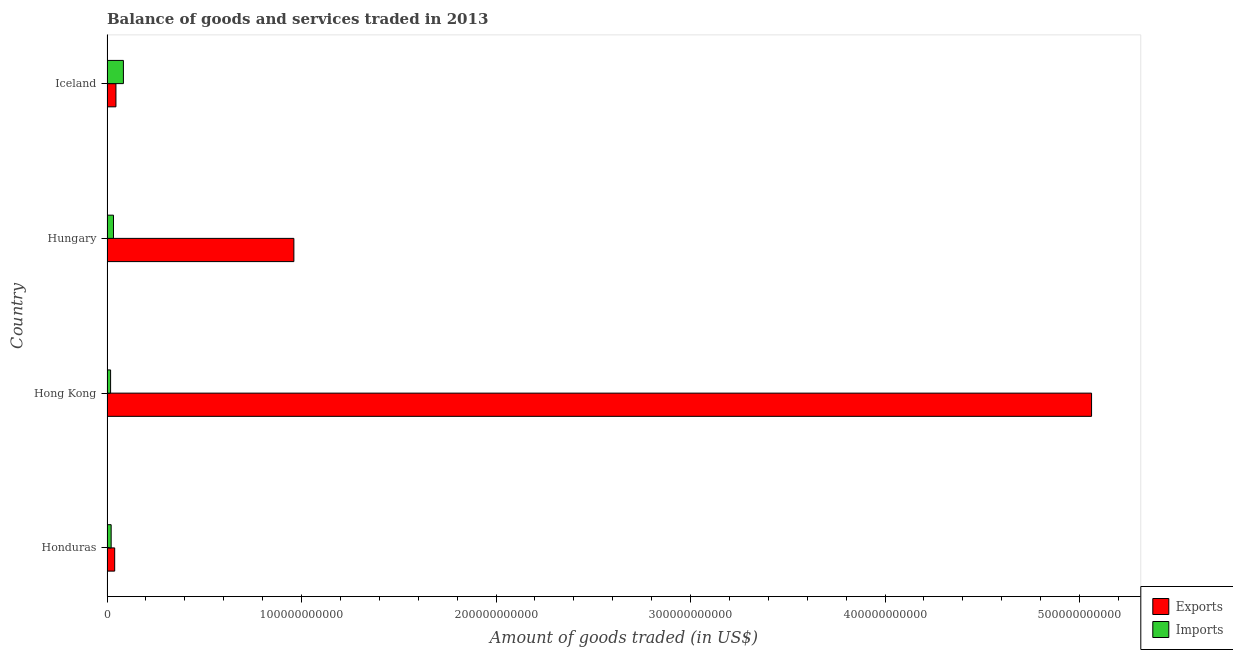How many different coloured bars are there?
Your answer should be very brief. 2. How many groups of bars are there?
Your answer should be compact. 4. Are the number of bars on each tick of the Y-axis equal?
Your answer should be very brief. Yes. How many bars are there on the 1st tick from the top?
Ensure brevity in your answer.  2. What is the label of the 1st group of bars from the top?
Give a very brief answer. Iceland. In how many cases, is the number of bars for a given country not equal to the number of legend labels?
Ensure brevity in your answer.  0. What is the amount of goods imported in Iceland?
Your answer should be compact. 8.43e+09. Across all countries, what is the maximum amount of goods imported?
Keep it short and to the point. 8.43e+09. Across all countries, what is the minimum amount of goods imported?
Your response must be concise. 1.85e+09. In which country was the amount of goods exported maximum?
Give a very brief answer. Hong Kong. In which country was the amount of goods exported minimum?
Give a very brief answer. Honduras. What is the total amount of goods imported in the graph?
Keep it short and to the point. 1.57e+1. What is the difference between the amount of goods imported in Honduras and that in Hong Kong?
Ensure brevity in your answer.  2.89e+08. What is the difference between the amount of goods imported in Hungary and the amount of goods exported in Honduras?
Provide a succinct answer. -6.21e+08. What is the average amount of goods imported per country?
Ensure brevity in your answer.  3.94e+09. What is the difference between the amount of goods exported and amount of goods imported in Hong Kong?
Your answer should be compact. 5.04e+11. In how many countries, is the amount of goods exported greater than 400000000000 US$?
Provide a short and direct response. 1. What is the ratio of the amount of goods imported in Hong Kong to that in Hungary?
Offer a terse response. 0.56. Is the amount of goods exported in Honduras less than that in Hong Kong?
Offer a terse response. Yes. What is the difference between the highest and the second highest amount of goods exported?
Provide a short and direct response. 4.10e+11. What is the difference between the highest and the lowest amount of goods imported?
Ensure brevity in your answer.  6.58e+09. In how many countries, is the amount of goods imported greater than the average amount of goods imported taken over all countries?
Keep it short and to the point. 1. Is the sum of the amount of goods imported in Hong Kong and Hungary greater than the maximum amount of goods exported across all countries?
Your answer should be compact. No. What does the 2nd bar from the top in Hong Kong represents?
Offer a terse response. Exports. What does the 1st bar from the bottom in Hungary represents?
Keep it short and to the point. Exports. How many bars are there?
Provide a succinct answer. 8. Are all the bars in the graph horizontal?
Make the answer very short. Yes. How many countries are there in the graph?
Provide a short and direct response. 4. What is the difference between two consecutive major ticks on the X-axis?
Offer a very short reply. 1.00e+11. Are the values on the major ticks of X-axis written in scientific E-notation?
Offer a very short reply. No. Does the graph contain any zero values?
Keep it short and to the point. No. How many legend labels are there?
Offer a very short reply. 2. What is the title of the graph?
Make the answer very short. Balance of goods and services traded in 2013. What is the label or title of the X-axis?
Make the answer very short. Amount of goods traded (in US$). What is the label or title of the Y-axis?
Provide a short and direct response. Country. What is the Amount of goods traded (in US$) of Exports in Honduras?
Ensure brevity in your answer.  3.95e+09. What is the Amount of goods traded (in US$) of Imports in Honduras?
Make the answer very short. 2.14e+09. What is the Amount of goods traded (in US$) in Exports in Hong Kong?
Give a very brief answer. 5.06e+11. What is the Amount of goods traded (in US$) in Imports in Hong Kong?
Ensure brevity in your answer.  1.85e+09. What is the Amount of goods traded (in US$) of Exports in Hungary?
Ensure brevity in your answer.  9.61e+1. What is the Amount of goods traded (in US$) in Imports in Hungary?
Offer a terse response. 3.33e+09. What is the Amount of goods traded (in US$) in Exports in Iceland?
Your answer should be compact. 4.59e+09. What is the Amount of goods traded (in US$) in Imports in Iceland?
Your answer should be very brief. 8.43e+09. Across all countries, what is the maximum Amount of goods traded (in US$) in Exports?
Provide a succinct answer. 5.06e+11. Across all countries, what is the maximum Amount of goods traded (in US$) of Imports?
Give a very brief answer. 8.43e+09. Across all countries, what is the minimum Amount of goods traded (in US$) of Exports?
Provide a short and direct response. 3.95e+09. Across all countries, what is the minimum Amount of goods traded (in US$) in Imports?
Your answer should be very brief. 1.85e+09. What is the total Amount of goods traded (in US$) in Exports in the graph?
Provide a short and direct response. 6.11e+11. What is the total Amount of goods traded (in US$) in Imports in the graph?
Ensure brevity in your answer.  1.57e+1. What is the difference between the Amount of goods traded (in US$) in Exports in Honduras and that in Hong Kong?
Offer a terse response. -5.02e+11. What is the difference between the Amount of goods traded (in US$) of Imports in Honduras and that in Hong Kong?
Give a very brief answer. 2.89e+08. What is the difference between the Amount of goods traded (in US$) of Exports in Honduras and that in Hungary?
Make the answer very short. -9.21e+1. What is the difference between the Amount of goods traded (in US$) of Imports in Honduras and that in Hungary?
Give a very brief answer. -1.19e+09. What is the difference between the Amount of goods traded (in US$) of Exports in Honduras and that in Iceland?
Your answer should be compact. -6.42e+08. What is the difference between the Amount of goods traded (in US$) in Imports in Honduras and that in Iceland?
Offer a terse response. -6.29e+09. What is the difference between the Amount of goods traded (in US$) in Exports in Hong Kong and that in Hungary?
Provide a short and direct response. 4.10e+11. What is the difference between the Amount of goods traded (in US$) in Imports in Hong Kong and that in Hungary?
Provide a short and direct response. -1.48e+09. What is the difference between the Amount of goods traded (in US$) in Exports in Hong Kong and that in Iceland?
Offer a very short reply. 5.02e+11. What is the difference between the Amount of goods traded (in US$) in Imports in Hong Kong and that in Iceland?
Make the answer very short. -6.58e+09. What is the difference between the Amount of goods traded (in US$) of Exports in Hungary and that in Iceland?
Your answer should be compact. 9.15e+1. What is the difference between the Amount of goods traded (in US$) in Imports in Hungary and that in Iceland?
Offer a terse response. -5.10e+09. What is the difference between the Amount of goods traded (in US$) in Exports in Honduras and the Amount of goods traded (in US$) in Imports in Hong Kong?
Offer a terse response. 2.10e+09. What is the difference between the Amount of goods traded (in US$) in Exports in Honduras and the Amount of goods traded (in US$) in Imports in Hungary?
Offer a very short reply. 6.21e+08. What is the difference between the Amount of goods traded (in US$) of Exports in Honduras and the Amount of goods traded (in US$) of Imports in Iceland?
Give a very brief answer. -4.48e+09. What is the difference between the Amount of goods traded (in US$) in Exports in Hong Kong and the Amount of goods traded (in US$) in Imports in Hungary?
Your response must be concise. 5.03e+11. What is the difference between the Amount of goods traded (in US$) in Exports in Hong Kong and the Amount of goods traded (in US$) in Imports in Iceland?
Ensure brevity in your answer.  4.98e+11. What is the difference between the Amount of goods traded (in US$) of Exports in Hungary and the Amount of goods traded (in US$) of Imports in Iceland?
Your answer should be compact. 8.77e+1. What is the average Amount of goods traded (in US$) of Exports per country?
Your answer should be very brief. 1.53e+11. What is the average Amount of goods traded (in US$) in Imports per country?
Keep it short and to the point. 3.94e+09. What is the difference between the Amount of goods traded (in US$) in Exports and Amount of goods traded (in US$) in Imports in Honduras?
Make the answer very short. 1.81e+09. What is the difference between the Amount of goods traded (in US$) in Exports and Amount of goods traded (in US$) in Imports in Hong Kong?
Offer a very short reply. 5.04e+11. What is the difference between the Amount of goods traded (in US$) of Exports and Amount of goods traded (in US$) of Imports in Hungary?
Offer a terse response. 9.28e+1. What is the difference between the Amount of goods traded (in US$) of Exports and Amount of goods traded (in US$) of Imports in Iceland?
Your answer should be very brief. -3.84e+09. What is the ratio of the Amount of goods traded (in US$) of Exports in Honduras to that in Hong Kong?
Your answer should be very brief. 0.01. What is the ratio of the Amount of goods traded (in US$) in Imports in Honduras to that in Hong Kong?
Your answer should be very brief. 1.16. What is the ratio of the Amount of goods traded (in US$) of Exports in Honduras to that in Hungary?
Offer a terse response. 0.04. What is the ratio of the Amount of goods traded (in US$) of Imports in Honduras to that in Hungary?
Keep it short and to the point. 0.64. What is the ratio of the Amount of goods traded (in US$) of Exports in Honduras to that in Iceland?
Your answer should be compact. 0.86. What is the ratio of the Amount of goods traded (in US$) in Imports in Honduras to that in Iceland?
Give a very brief answer. 0.25. What is the ratio of the Amount of goods traded (in US$) of Exports in Hong Kong to that in Hungary?
Your answer should be compact. 5.27. What is the ratio of the Amount of goods traded (in US$) of Imports in Hong Kong to that in Hungary?
Keep it short and to the point. 0.55. What is the ratio of the Amount of goods traded (in US$) of Exports in Hong Kong to that in Iceland?
Provide a succinct answer. 110.22. What is the ratio of the Amount of goods traded (in US$) in Imports in Hong Kong to that in Iceland?
Provide a succinct answer. 0.22. What is the ratio of the Amount of goods traded (in US$) in Exports in Hungary to that in Iceland?
Ensure brevity in your answer.  20.92. What is the ratio of the Amount of goods traded (in US$) in Imports in Hungary to that in Iceland?
Give a very brief answer. 0.39. What is the difference between the highest and the second highest Amount of goods traded (in US$) of Exports?
Offer a very short reply. 4.10e+11. What is the difference between the highest and the second highest Amount of goods traded (in US$) of Imports?
Your answer should be compact. 5.10e+09. What is the difference between the highest and the lowest Amount of goods traded (in US$) of Exports?
Provide a short and direct response. 5.02e+11. What is the difference between the highest and the lowest Amount of goods traded (in US$) of Imports?
Make the answer very short. 6.58e+09. 